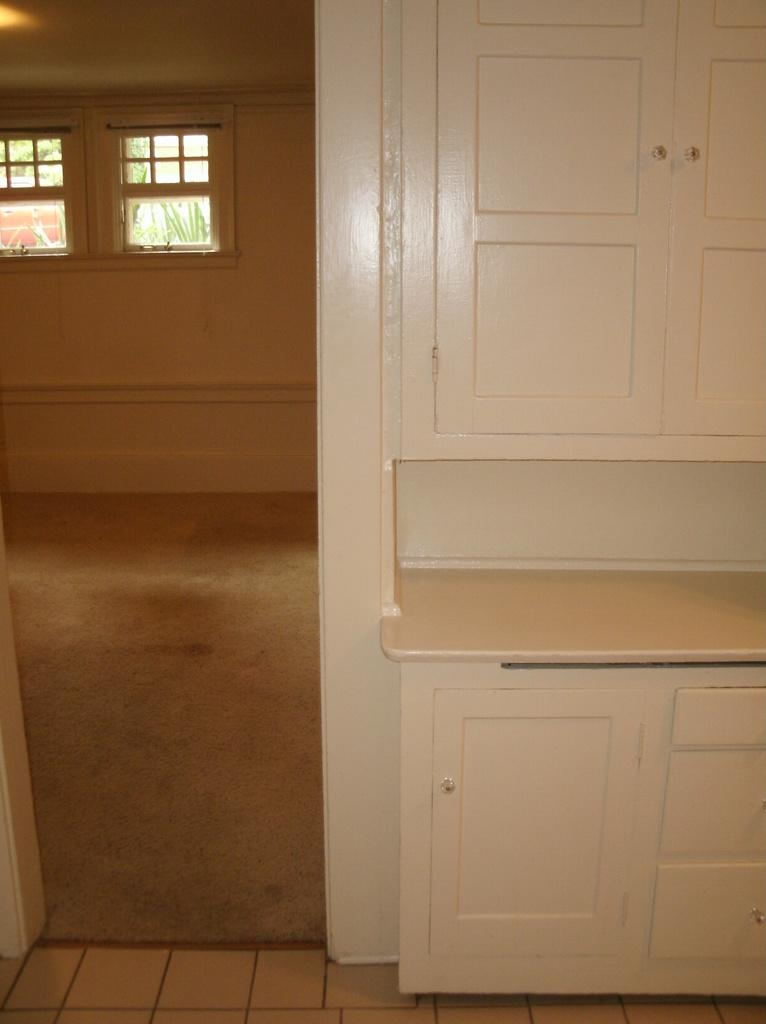What type of furniture is present in the image? There are cupboards with doors in the image. Can you see another room in the image? Yes, there is another room visible in the image. What feature of the room allows natural light to enter? The room has windows. What can be seen beneath the furniture and people in the image? The floor is visible in the image. How many plastic pigs are visible in the image? There are no plastic pigs present in the image. Are there any dogs visible in the image? There are no dogs present in the image. 